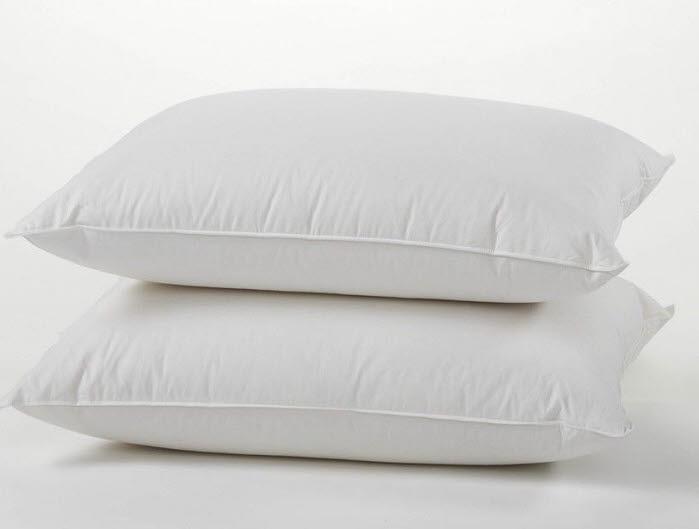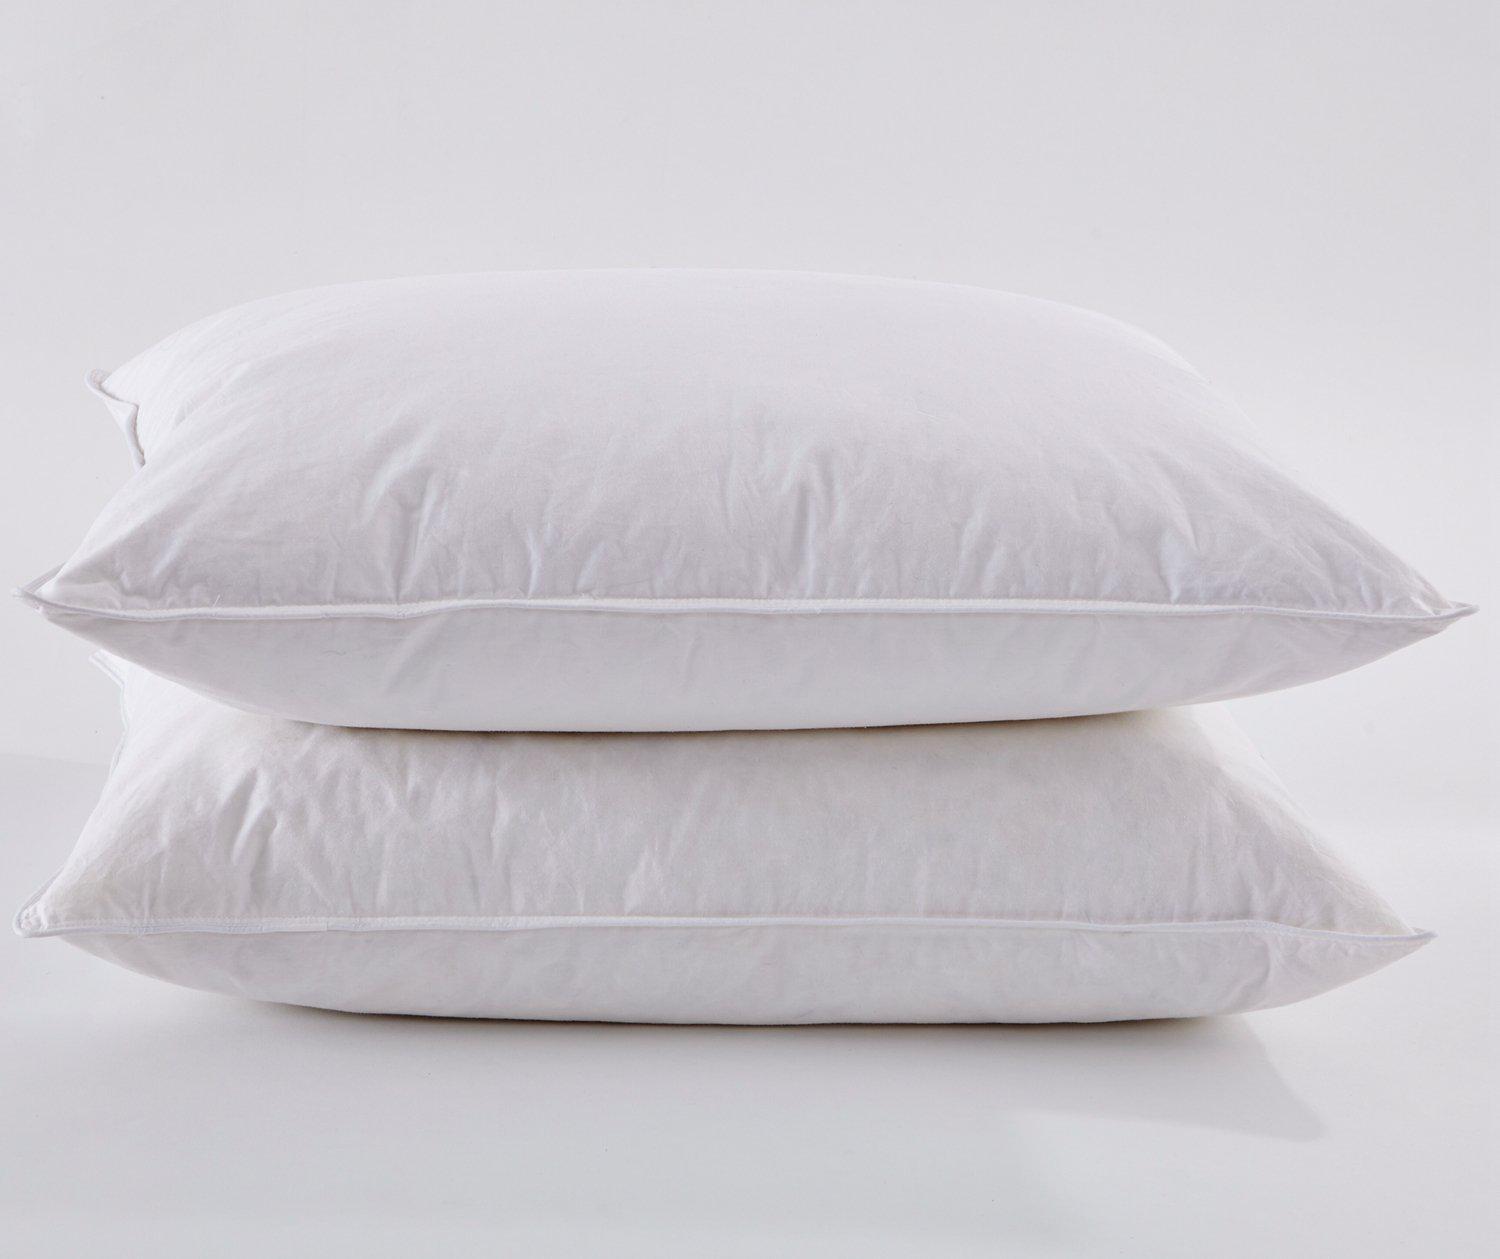The first image is the image on the left, the second image is the image on the right. Examine the images to the left and right. Is the description "Each image contains a stack of two white pillows, and no pillow stacks are sitting on a textured surface." accurate? Answer yes or no. Yes. 